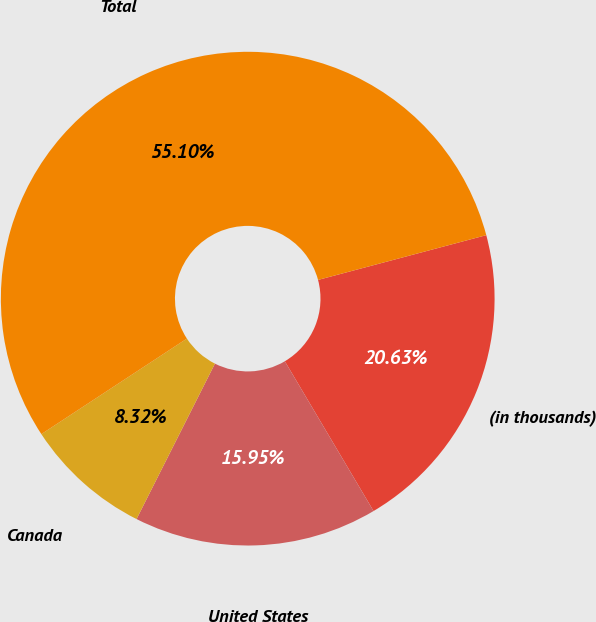<chart> <loc_0><loc_0><loc_500><loc_500><pie_chart><fcel>(in thousands)<fcel>United States<fcel>Canada<fcel>Total<nl><fcel>20.63%<fcel>15.95%<fcel>8.32%<fcel>55.11%<nl></chart> 